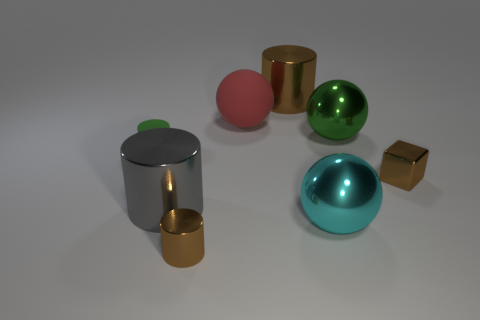Subtract all tiny shiny cylinders. How many cylinders are left? 3 Add 2 big cyan objects. How many objects exist? 10 Subtract 2 cylinders. How many cylinders are left? 2 Subtract all green cylinders. How many cylinders are left? 3 Subtract all green cylinders. How many purple spheres are left? 0 Add 7 large cyan metallic balls. How many large cyan metallic balls exist? 8 Subtract 0 brown balls. How many objects are left? 8 Subtract all blocks. How many objects are left? 7 Subtract all green cubes. Subtract all blue cylinders. How many cubes are left? 1 Subtract all gray shiny cylinders. Subtract all tiny green matte cylinders. How many objects are left? 6 